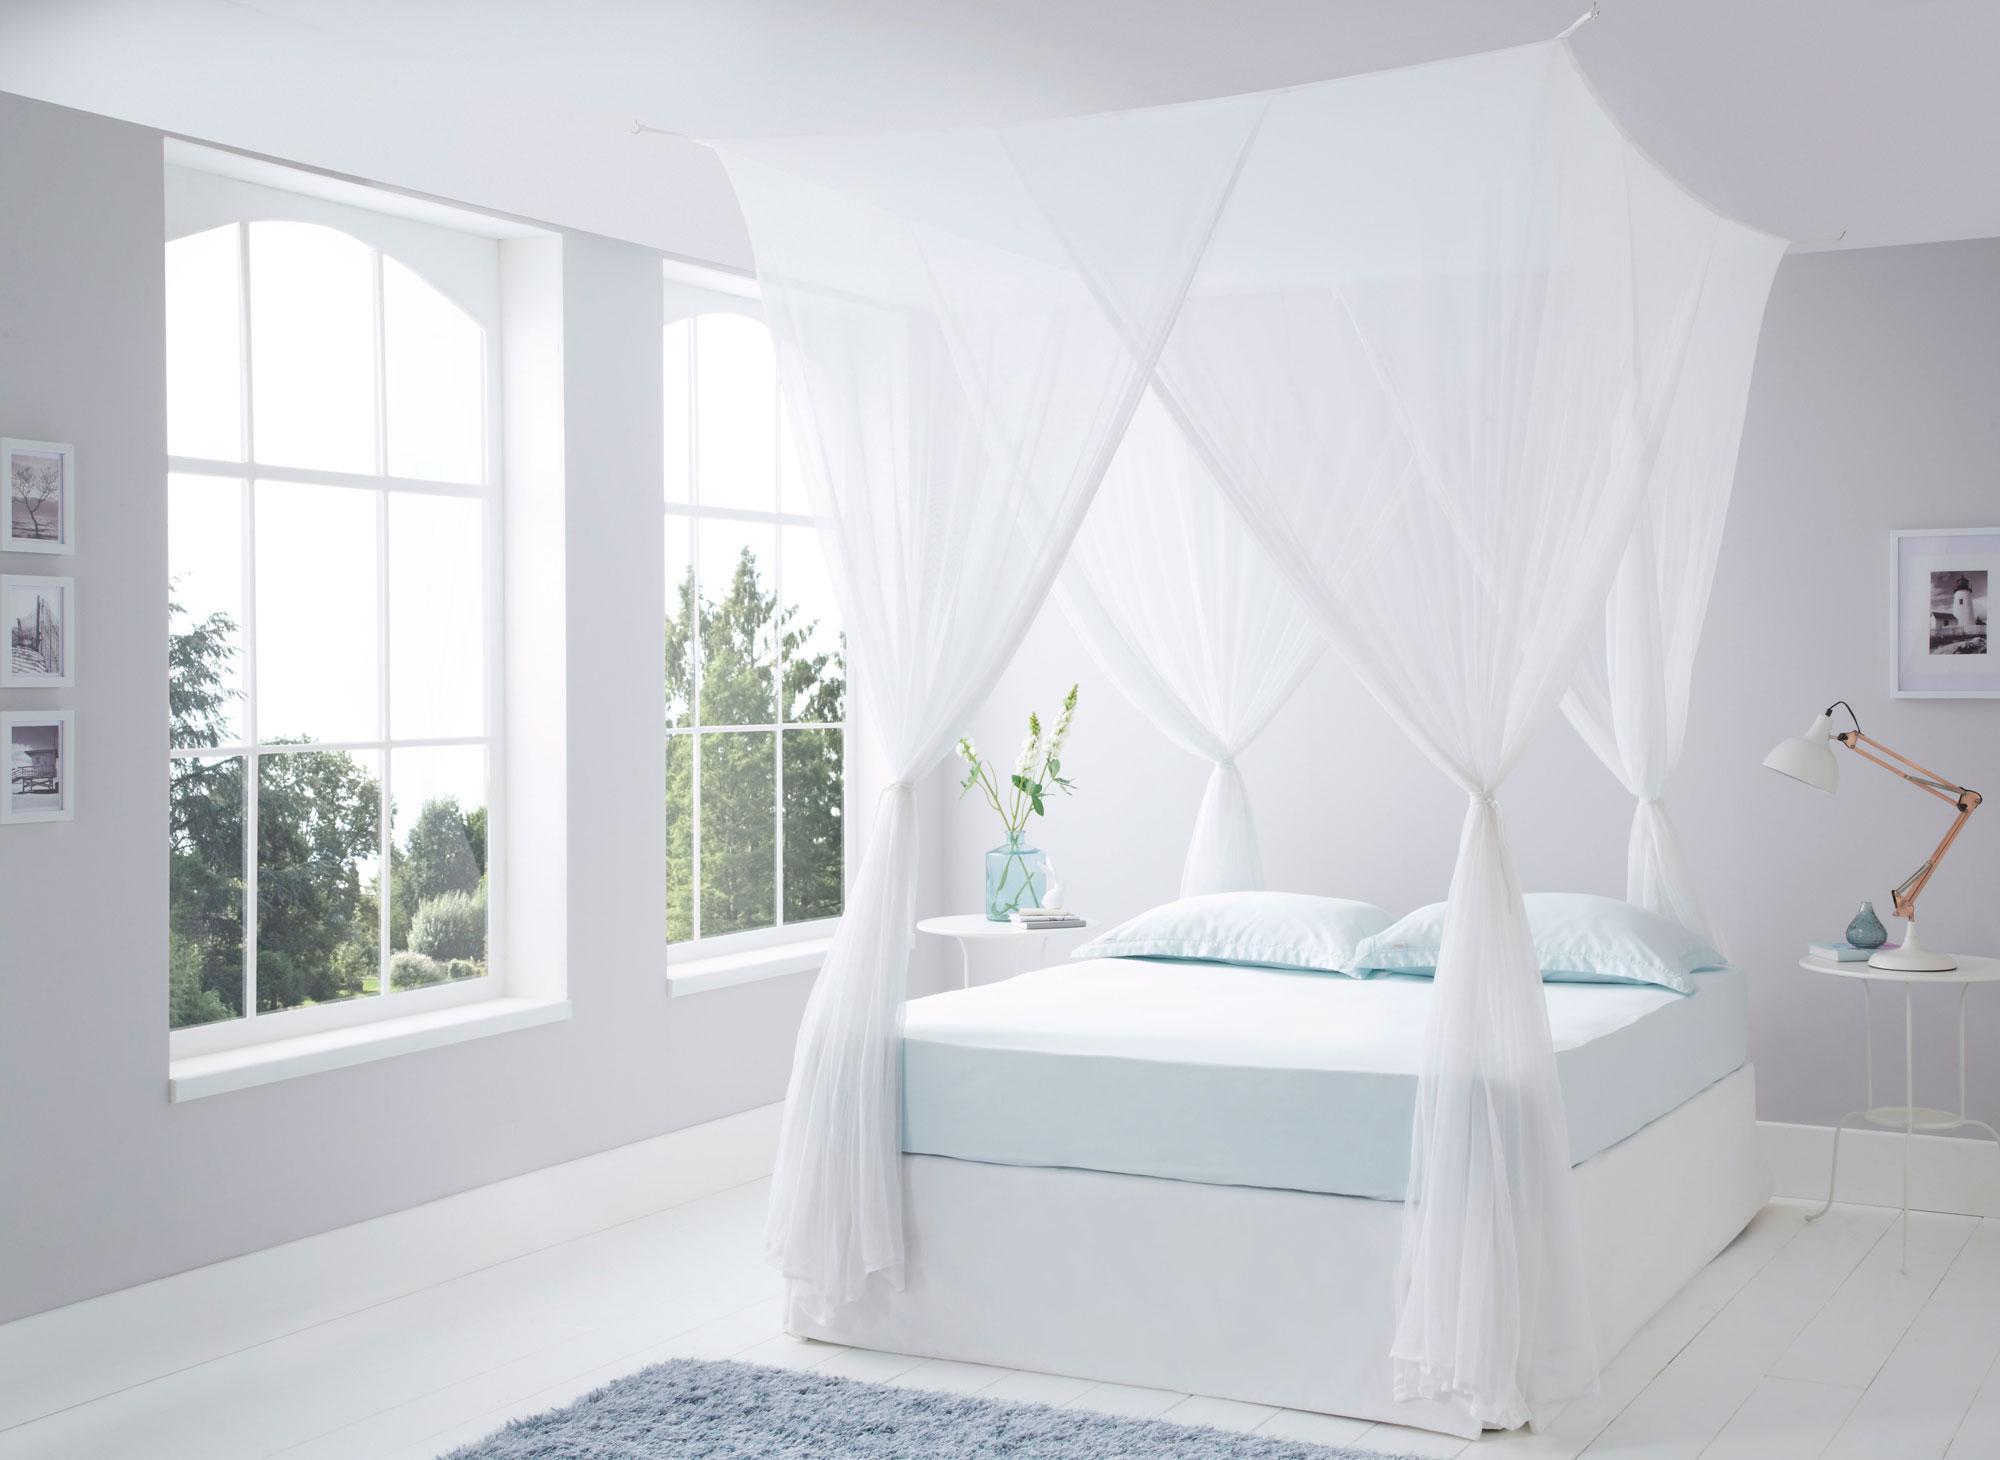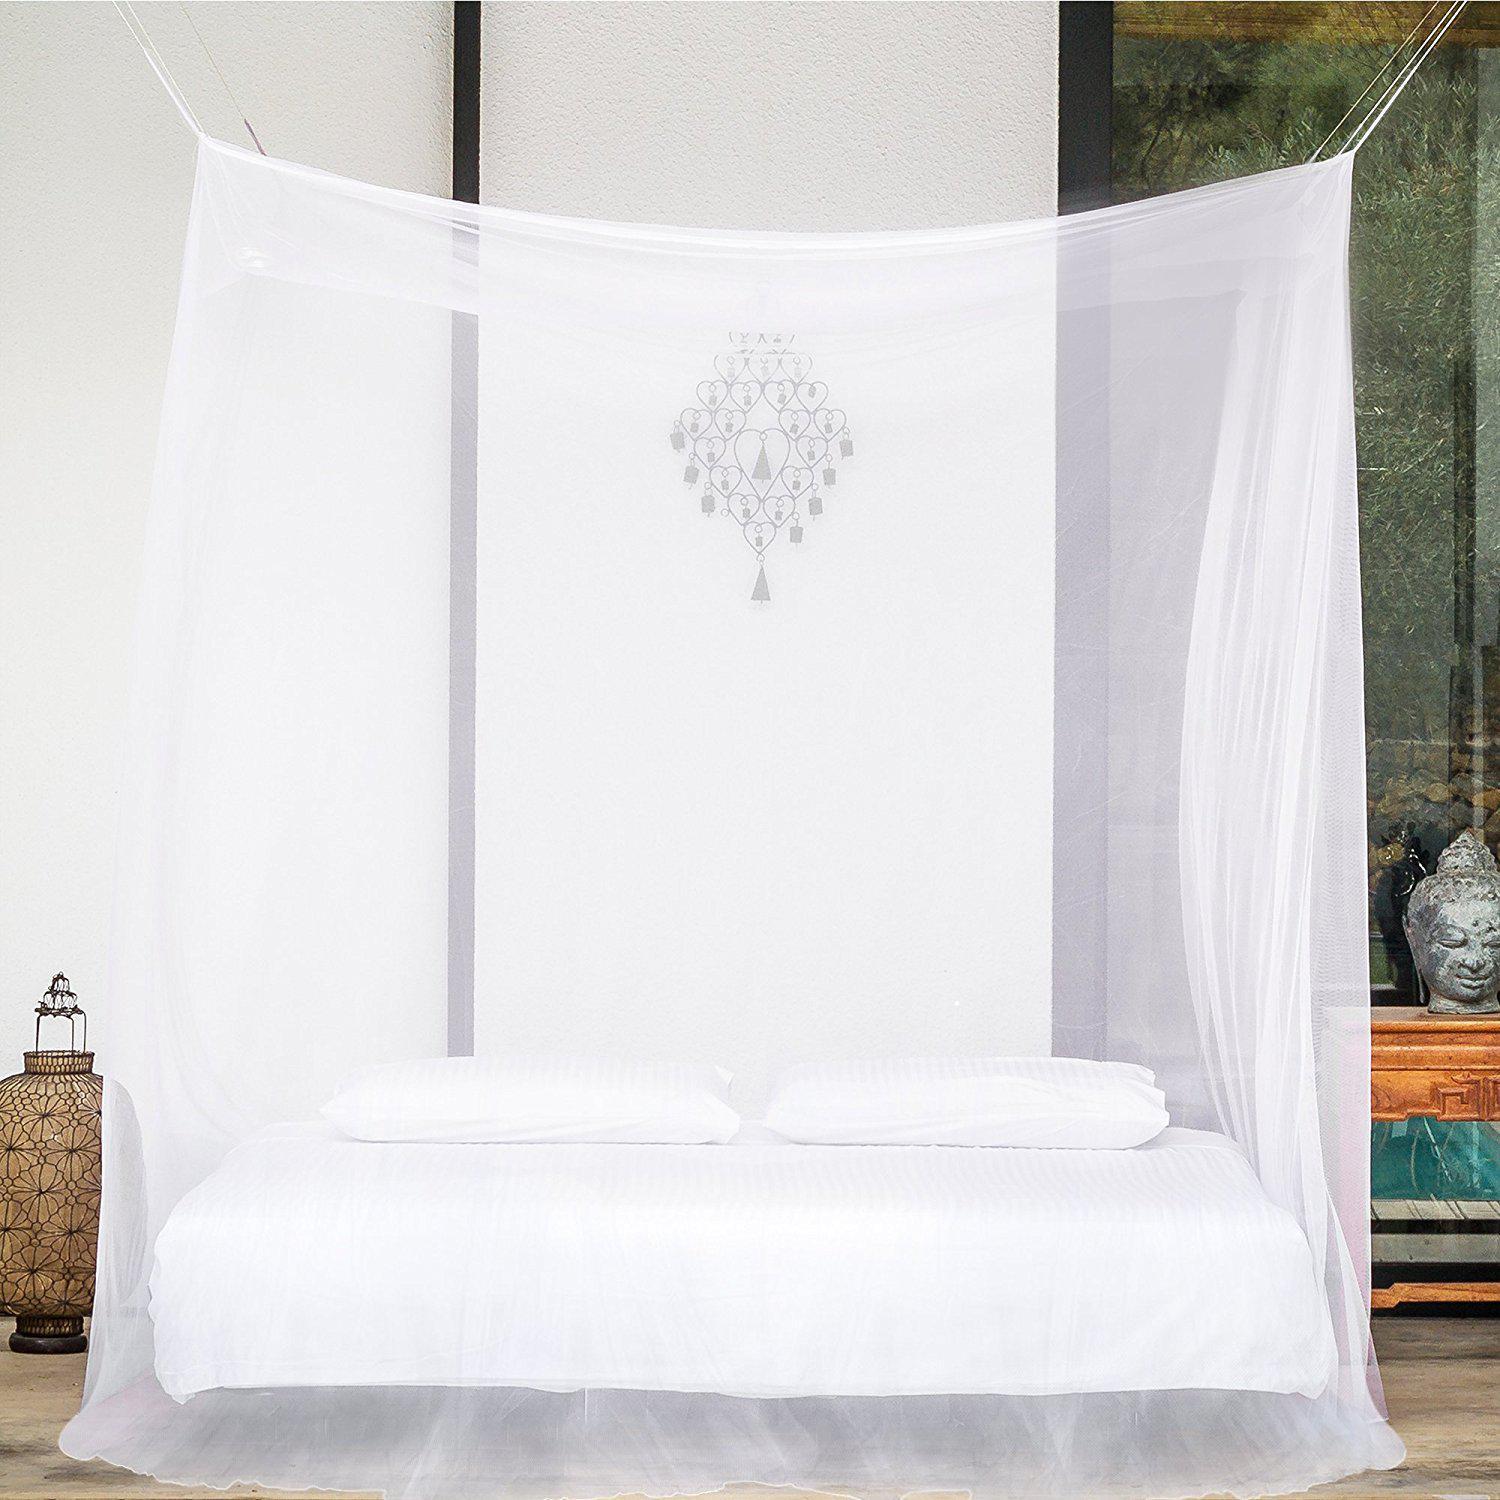The first image is the image on the left, the second image is the image on the right. Assess this claim about the two images: "There are two white square canopies.". Correct or not? Answer yes or no. Yes. The first image is the image on the left, the second image is the image on the right. For the images shown, is this caption "Exactly one bed net is attached to the ceiling." true? Answer yes or no. No. 